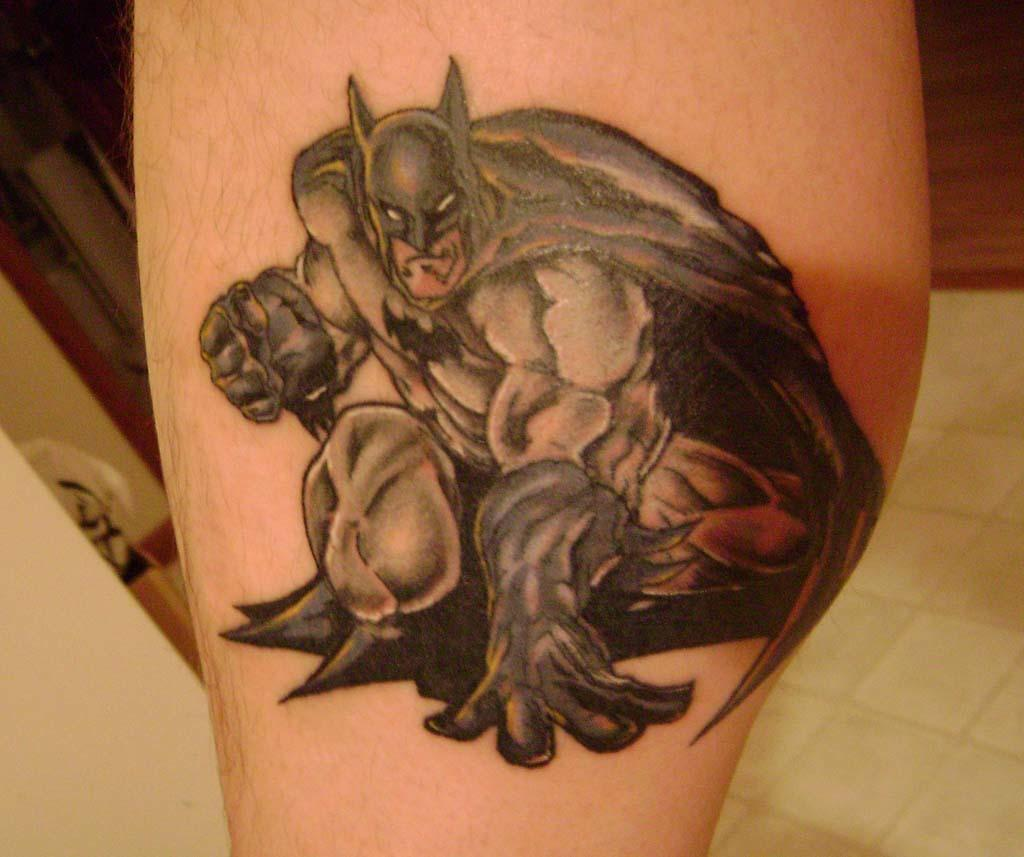What type of tattoo is visible in the image? There is a Batman tattoo in the image. Where is the tattoo located on the person's body? The tattoo is on a person's body part, but the specific location is not mentioned in the facts. What color is the girl's hair in the image? There is no girl present in the image; it only features a Batman tattoo. How many chairs are visible in the image? There are no chairs visible in the image; it only features a Batman tattoo. 